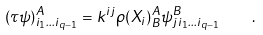Convert formula to latex. <formula><loc_0><loc_0><loc_500><loc_500>( { \tau } \psi ) _ { i _ { 1 } \dots i _ { q - 1 } } ^ { A } = k ^ { i j } \rho ( X _ { i } ) ^ { A } _ { B } \psi _ { j i _ { 1 } \dots i _ { q - 1 } } ^ { B } \quad .</formula> 